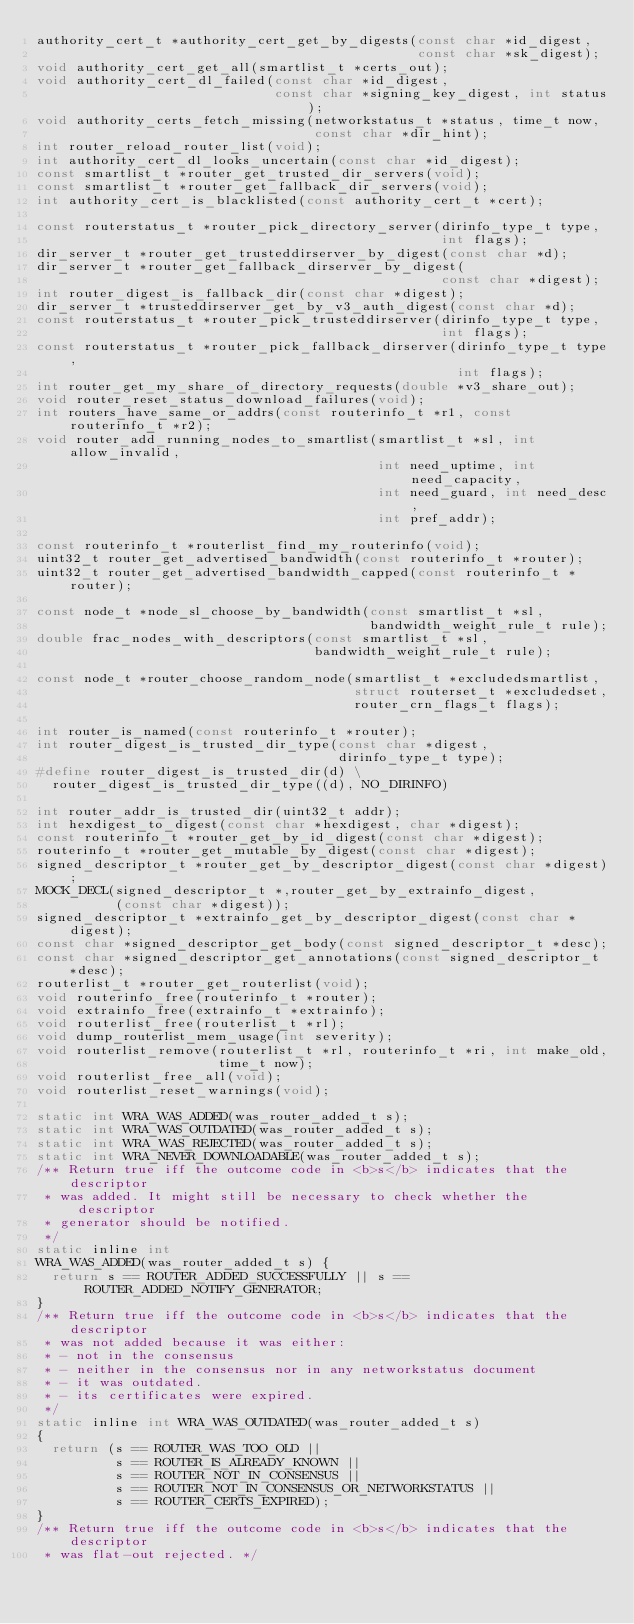<code> <loc_0><loc_0><loc_500><loc_500><_C_>authority_cert_t *authority_cert_get_by_digests(const char *id_digest,
                                                const char *sk_digest);
void authority_cert_get_all(smartlist_t *certs_out);
void authority_cert_dl_failed(const char *id_digest,
                              const char *signing_key_digest, int status);
void authority_certs_fetch_missing(networkstatus_t *status, time_t now,
                                   const char *dir_hint);
int router_reload_router_list(void);
int authority_cert_dl_looks_uncertain(const char *id_digest);
const smartlist_t *router_get_trusted_dir_servers(void);
const smartlist_t *router_get_fallback_dir_servers(void);
int authority_cert_is_blacklisted(const authority_cert_t *cert);

const routerstatus_t *router_pick_directory_server(dirinfo_type_t type,
                                                   int flags);
dir_server_t *router_get_trusteddirserver_by_digest(const char *d);
dir_server_t *router_get_fallback_dirserver_by_digest(
                                                   const char *digest);
int router_digest_is_fallback_dir(const char *digest);
dir_server_t *trusteddirserver_get_by_v3_auth_digest(const char *d);
const routerstatus_t *router_pick_trusteddirserver(dirinfo_type_t type,
                                                   int flags);
const routerstatus_t *router_pick_fallback_dirserver(dirinfo_type_t type,
                                                     int flags);
int router_get_my_share_of_directory_requests(double *v3_share_out);
void router_reset_status_download_failures(void);
int routers_have_same_or_addrs(const routerinfo_t *r1, const routerinfo_t *r2);
void router_add_running_nodes_to_smartlist(smartlist_t *sl, int allow_invalid,
                                           int need_uptime, int need_capacity,
                                           int need_guard, int need_desc,
                                           int pref_addr);

const routerinfo_t *routerlist_find_my_routerinfo(void);
uint32_t router_get_advertised_bandwidth(const routerinfo_t *router);
uint32_t router_get_advertised_bandwidth_capped(const routerinfo_t *router);

const node_t *node_sl_choose_by_bandwidth(const smartlist_t *sl,
                                          bandwidth_weight_rule_t rule);
double frac_nodes_with_descriptors(const smartlist_t *sl,
                                   bandwidth_weight_rule_t rule);

const node_t *router_choose_random_node(smartlist_t *excludedsmartlist,
                                        struct routerset_t *excludedset,
                                        router_crn_flags_t flags);

int router_is_named(const routerinfo_t *router);
int router_digest_is_trusted_dir_type(const char *digest,
                                      dirinfo_type_t type);
#define router_digest_is_trusted_dir(d) \
  router_digest_is_trusted_dir_type((d), NO_DIRINFO)

int router_addr_is_trusted_dir(uint32_t addr);
int hexdigest_to_digest(const char *hexdigest, char *digest);
const routerinfo_t *router_get_by_id_digest(const char *digest);
routerinfo_t *router_get_mutable_by_digest(const char *digest);
signed_descriptor_t *router_get_by_descriptor_digest(const char *digest);
MOCK_DECL(signed_descriptor_t *,router_get_by_extrainfo_digest,
          (const char *digest));
signed_descriptor_t *extrainfo_get_by_descriptor_digest(const char *digest);
const char *signed_descriptor_get_body(const signed_descriptor_t *desc);
const char *signed_descriptor_get_annotations(const signed_descriptor_t *desc);
routerlist_t *router_get_routerlist(void);
void routerinfo_free(routerinfo_t *router);
void extrainfo_free(extrainfo_t *extrainfo);
void routerlist_free(routerlist_t *rl);
void dump_routerlist_mem_usage(int severity);
void routerlist_remove(routerlist_t *rl, routerinfo_t *ri, int make_old,
                       time_t now);
void routerlist_free_all(void);
void routerlist_reset_warnings(void);

static int WRA_WAS_ADDED(was_router_added_t s);
static int WRA_WAS_OUTDATED(was_router_added_t s);
static int WRA_WAS_REJECTED(was_router_added_t s);
static int WRA_NEVER_DOWNLOADABLE(was_router_added_t s);
/** Return true iff the outcome code in <b>s</b> indicates that the descriptor
 * was added. It might still be necessary to check whether the descriptor
 * generator should be notified.
 */
static inline int
WRA_WAS_ADDED(was_router_added_t s) {
  return s == ROUTER_ADDED_SUCCESSFULLY || s == ROUTER_ADDED_NOTIFY_GENERATOR;
}
/** Return true iff the outcome code in <b>s</b> indicates that the descriptor
 * was not added because it was either:
 * - not in the consensus
 * - neither in the consensus nor in any networkstatus document
 * - it was outdated.
 * - its certificates were expired.
 */
static inline int WRA_WAS_OUTDATED(was_router_added_t s)
{
  return (s == ROUTER_WAS_TOO_OLD ||
          s == ROUTER_IS_ALREADY_KNOWN ||
          s == ROUTER_NOT_IN_CONSENSUS ||
          s == ROUTER_NOT_IN_CONSENSUS_OR_NETWORKSTATUS ||
          s == ROUTER_CERTS_EXPIRED);
}
/** Return true iff the outcome code in <b>s</b> indicates that the descriptor
 * was flat-out rejected. */</code> 